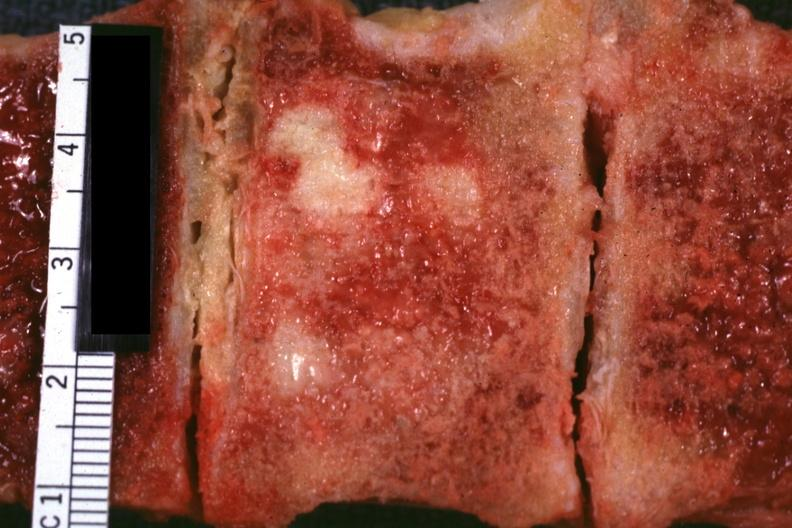what is excellent vertebral body primary adenocarcinoma?
Answer the question using a single word or phrase. Prostate 